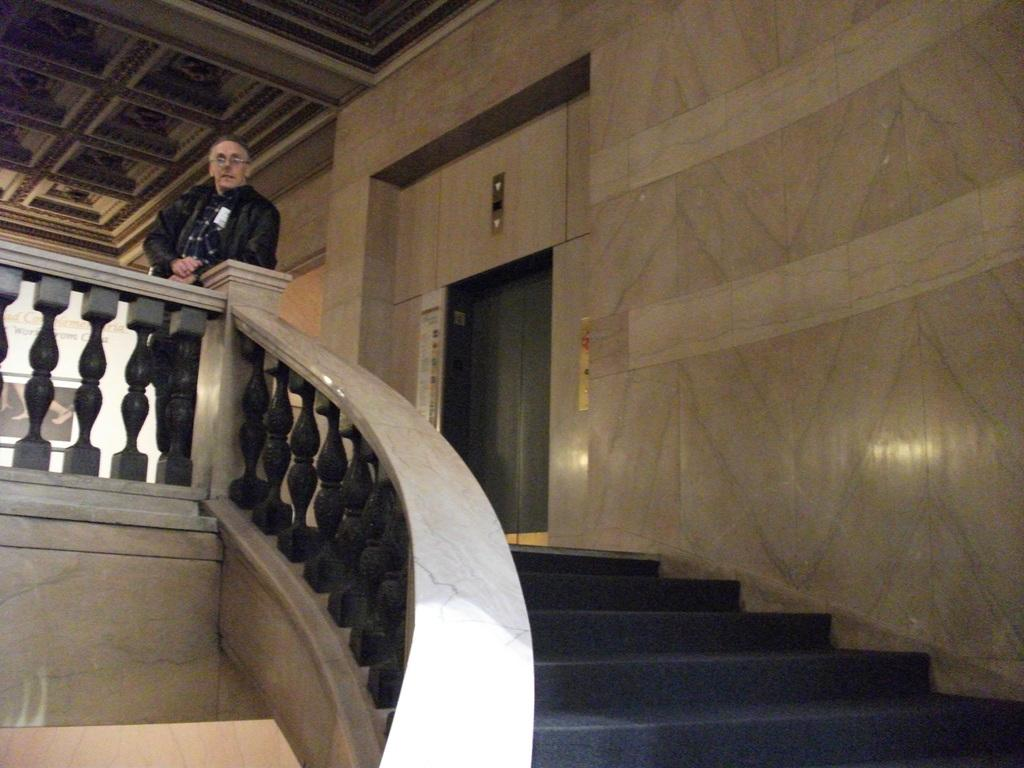Where was the image taken? The image was taken in a building. What can be seen in the foreground of the image? There is a staircase in the foreground of the image. What is located in the center of the image? There is a person and a lift in the center of the image. What part of the building can be seen at the top of the image? The ceiling is visible at the top of the image. What type of disease is the person in the image suffering from? There is no indication in the image that the person is suffering from any disease. How does the building in the image expand to accommodate more people? The image does not show any expansion of the building; it only shows a person, a lift, and a staircase. 